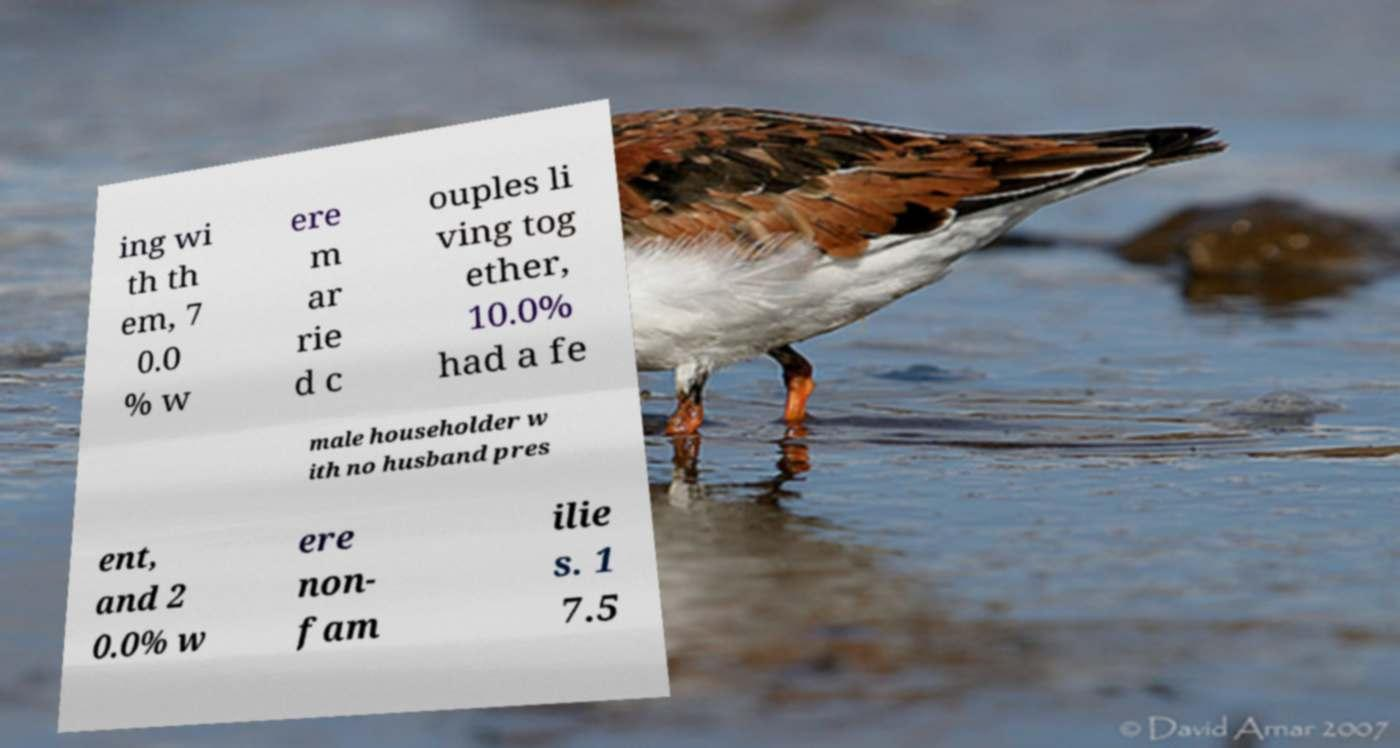There's text embedded in this image that I need extracted. Can you transcribe it verbatim? ing wi th th em, 7 0.0 % w ere m ar rie d c ouples li ving tog ether, 10.0% had a fe male householder w ith no husband pres ent, and 2 0.0% w ere non- fam ilie s. 1 7.5 